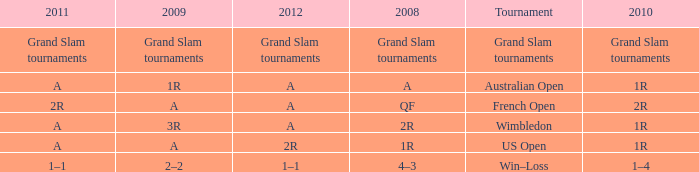Name the 2011 when 2010 is 2r 2R. 